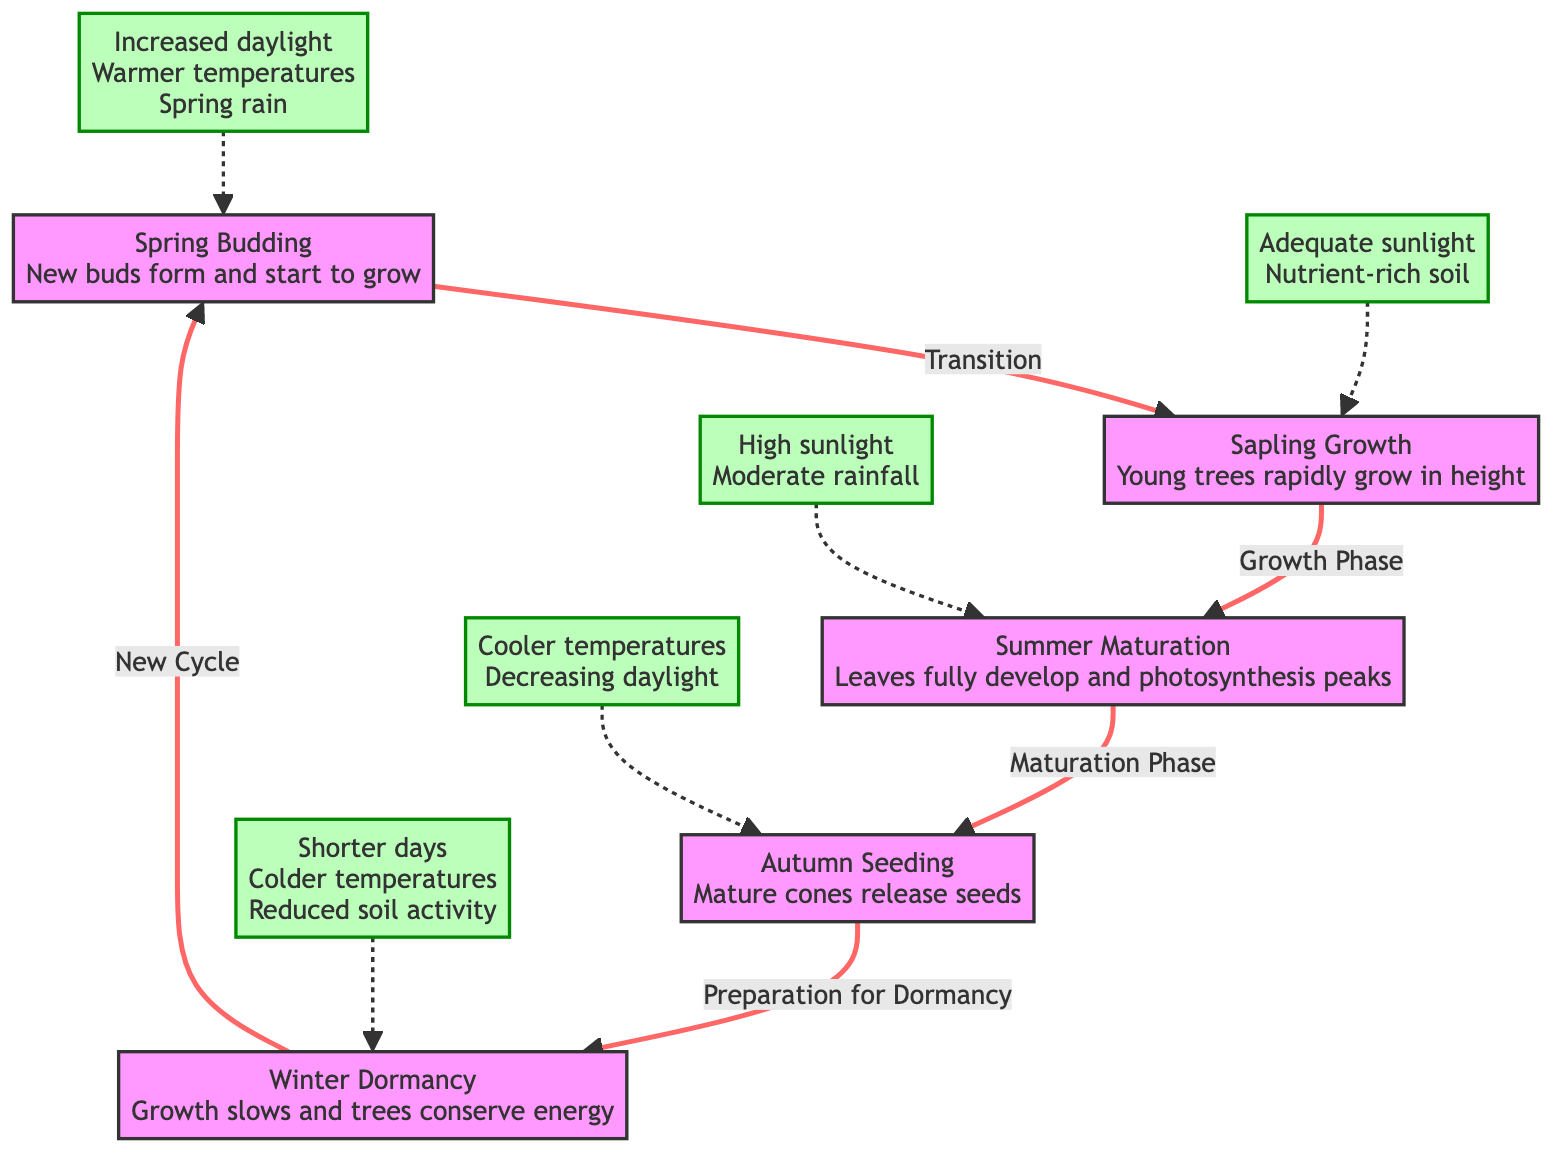What is the first stage of the seasonal life cycle? The diagram shows that the first stage is "Spring Budding" where new buds form and start to grow. This is indicated by the starting point of the flowchart.
Answer: Spring Budding How many growth stages are there in the life cycle? Counting the nodes in the diagram, there are five distinct stages clearly indicated. They are Spring Budding, Sapling Growth, Summer Maturation, Autumn Seeding, and Winter Dormancy.
Answer: 5 Which environmental factors affect the "Summer Maturation" stage? The diagram specifies that the factors affecting Summer Maturation include "High sunlight" and "Moderate rainfall." This can be identified from the environmental factors connecting to this growth phase.
Answer: High sunlight, Moderate rainfall What is associated with the "Autumn Seeding" stage? According to the diagram, the "Autumn Seeding" stage is associated with "Mature cones release seeds." This is a direct description from the node representing this stage.
Answer: Mature cones release seeds What follows after the "Winter Dormancy" stage? The diagram indicates that the next phase after "Winter Dormancy" is "Spring Budding," completing the cycle. This can be traced through the directed flow of the diagram.
Answer: Spring Budding What happens to trees during "Winter Dormancy"? The diagram explains that during "Winter Dormancy," trees "Conserve energy" as growth slows. This is highlighted in the description of that growth stage.
Answer: Conserve energy Which environmental factor is linked to "Spring Budding"? The environmental factors that influence "Spring Budding" include "Increased daylight," "Warmer temperatures," and "Spring rain." This is noted at the connection line leading to this stage.
Answer: Increased daylight, Warmer temperatures, Spring rain What stage involves the release of seeds? "Autumn Seeding" is the specific stage where mature cones release seeds, as clearly designated in the diagram.
Answer: Autumn Seeding Which stage occurs after "Sapling Growth"? The flowchart indicates that the stage following "Sapling Growth" is "Summer Maturation." This can be visualized by tracing the arrow from one stage to the next.
Answer: Summer Maturation 